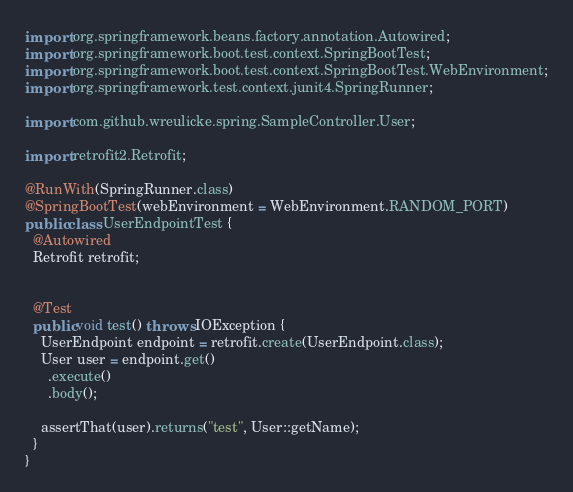<code> <loc_0><loc_0><loc_500><loc_500><_Java_>import org.springframework.beans.factory.annotation.Autowired;
import org.springframework.boot.test.context.SpringBootTest;
import org.springframework.boot.test.context.SpringBootTest.WebEnvironment;
import org.springframework.test.context.junit4.SpringRunner;

import com.github.wreulicke.spring.SampleController.User;

import retrofit2.Retrofit;

@RunWith(SpringRunner.class)
@SpringBootTest(webEnvironment = WebEnvironment.RANDOM_PORT)
public class UserEndpointTest {
  @Autowired
  Retrofit retrofit;


  @Test
  public void test() throws IOException {
    UserEndpoint endpoint = retrofit.create(UserEndpoint.class);
    User user = endpoint.get()
      .execute()
      .body();

    assertThat(user).returns("test", User::getName);
  }
}
</code> 